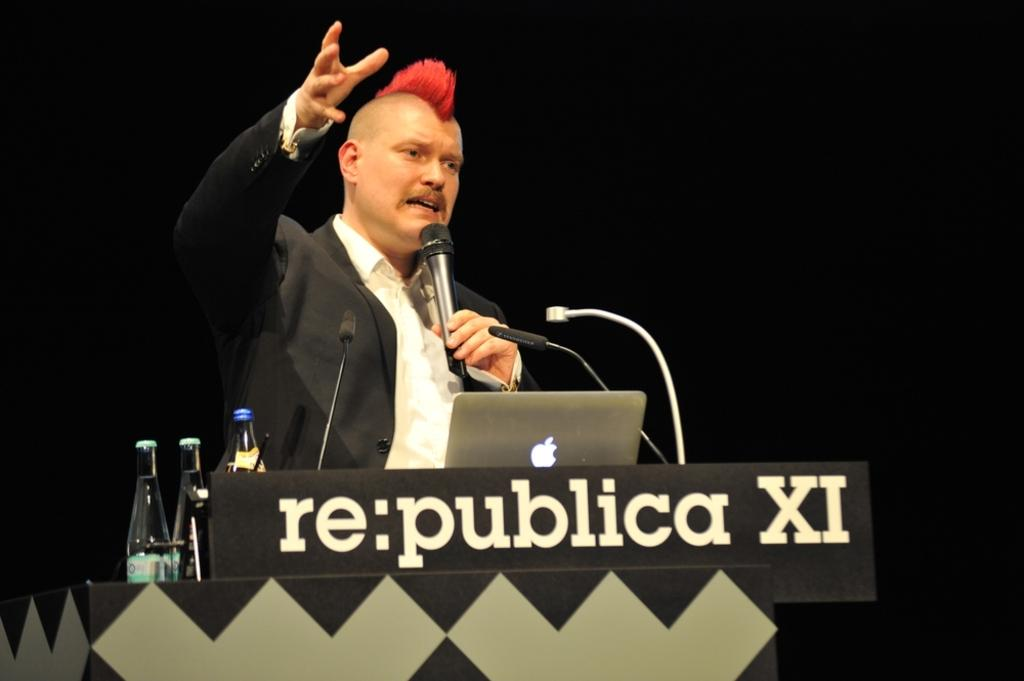What is the main object in the image? There is a podium in the image. Who or what is near the podium? There is a person in the image. What equipment is present for communication? There are microphones in the image. What device is used for presenting information or displaying visuals? There is a laptop in the image. What type of items can be seen in the image? There are bottles in the image. What color is the background of the image? The background of the image is black. How many trains are visible in the image? There are no trains present in the image. Is there a guitar being played in the image? There is no guitar present in the image. 